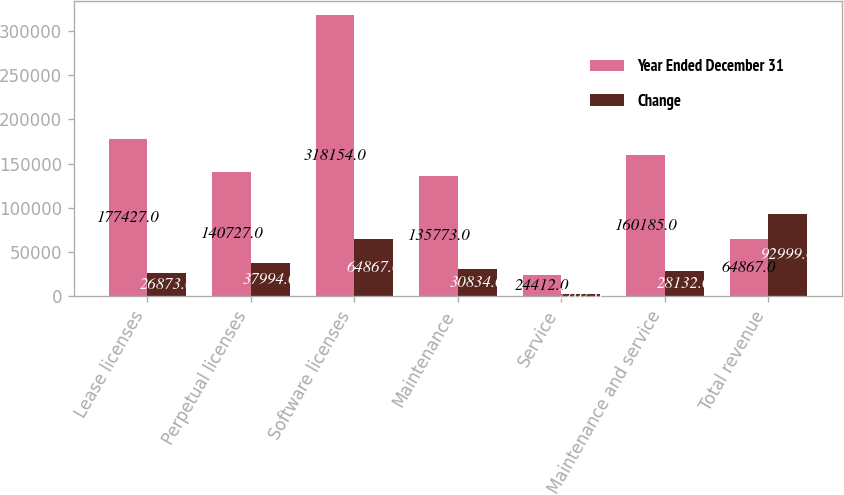Convert chart. <chart><loc_0><loc_0><loc_500><loc_500><stacked_bar_chart><ecel><fcel>Lease licenses<fcel>Perpetual licenses<fcel>Software licenses<fcel>Maintenance<fcel>Service<fcel>Maintenance and service<fcel>Total revenue<nl><fcel>Year Ended December 31<fcel>177427<fcel>140727<fcel>318154<fcel>135773<fcel>24412<fcel>160185<fcel>64867<nl><fcel>Change<fcel>26873<fcel>37994<fcel>64867<fcel>30834<fcel>2702<fcel>28132<fcel>92999<nl></chart> 